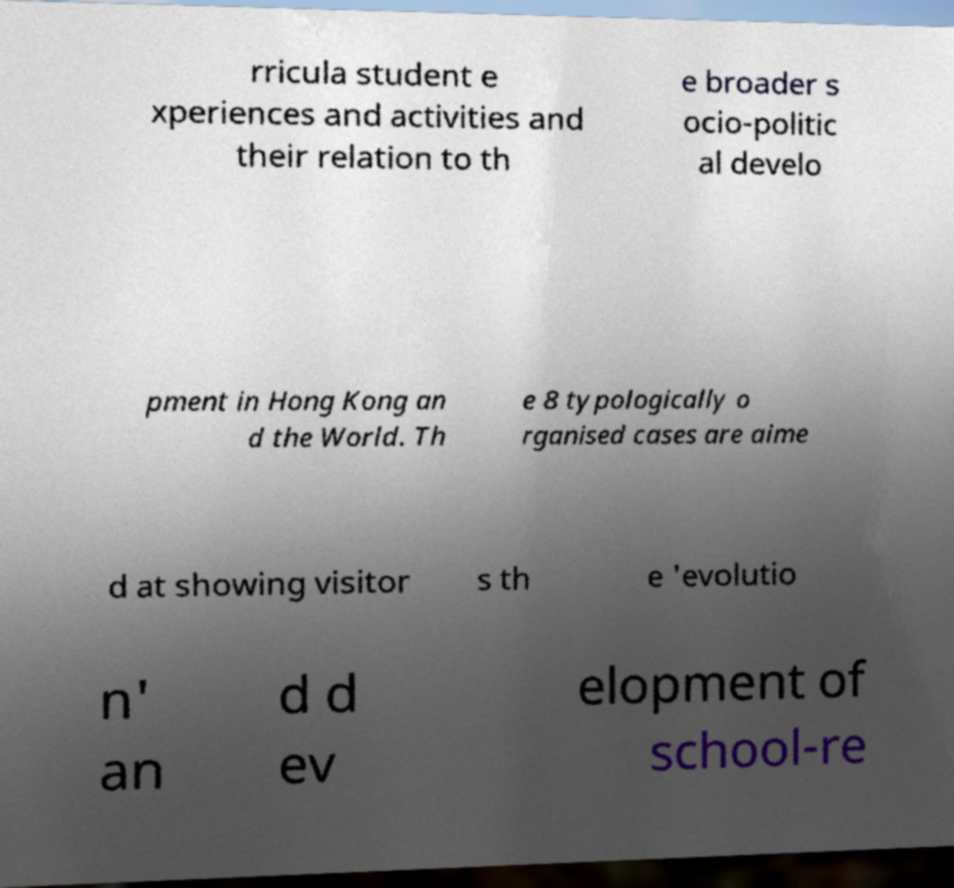I need the written content from this picture converted into text. Can you do that? rricula student e xperiences and activities and their relation to th e broader s ocio-politic al develo pment in Hong Kong an d the World. Th e 8 typologically o rganised cases are aime d at showing visitor s th e 'evolutio n' an d d ev elopment of school-re 